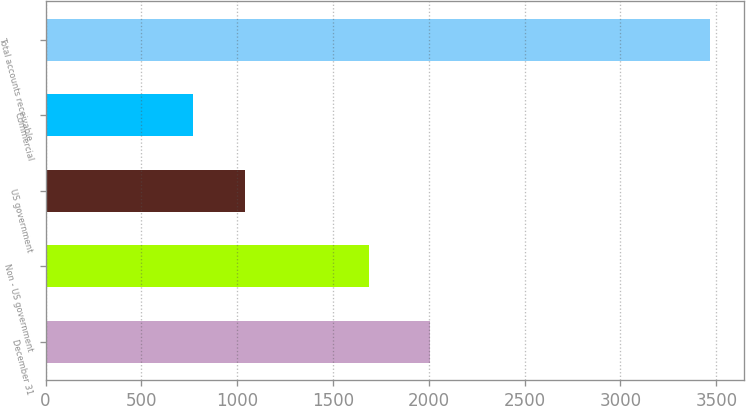<chart> <loc_0><loc_0><loc_500><loc_500><bar_chart><fcel>December 31<fcel>Non - US government<fcel>US government<fcel>Commercial<fcel>Total accounts receivable<nl><fcel>2008<fcel>1689<fcel>1040.8<fcel>771<fcel>3469<nl></chart> 